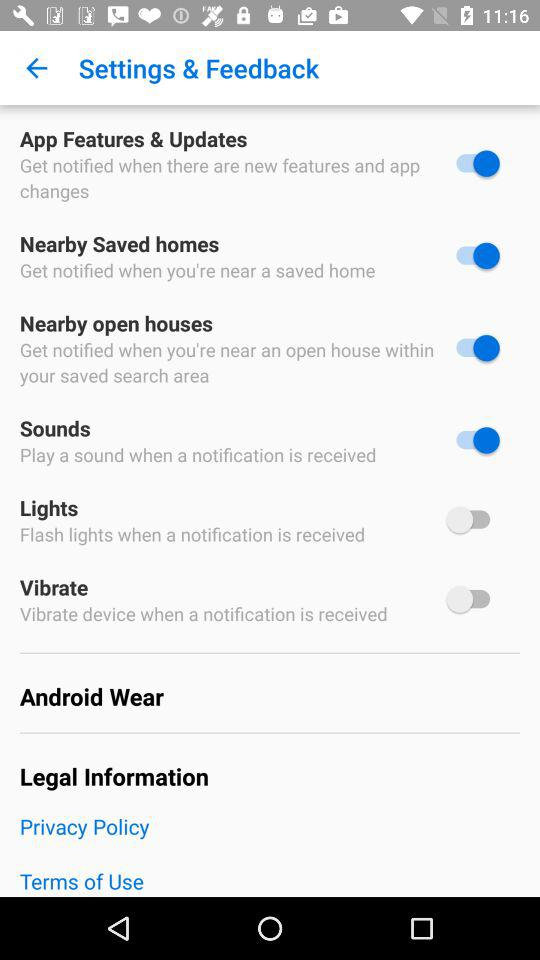What is the status of "App Features & Updates"? The status is "on". 